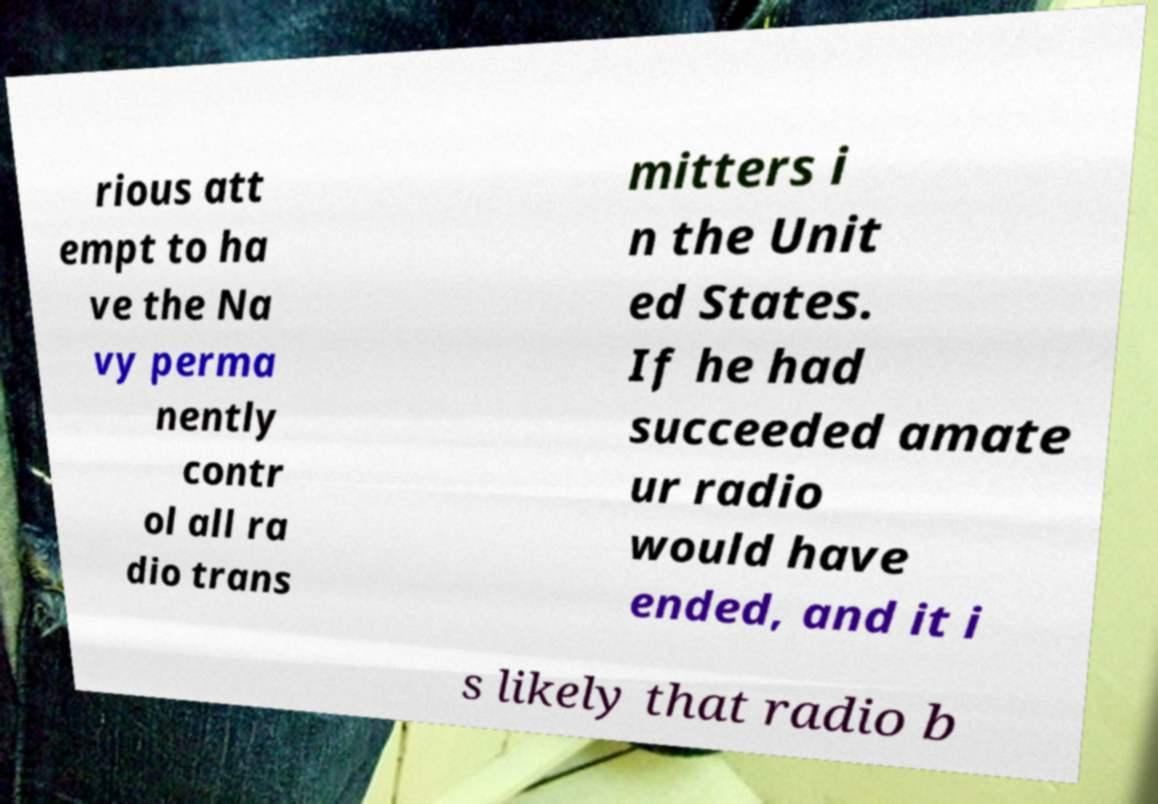Can you read and provide the text displayed in the image?This photo seems to have some interesting text. Can you extract and type it out for me? rious att empt to ha ve the Na vy perma nently contr ol all ra dio trans mitters i n the Unit ed States. If he had succeeded amate ur radio would have ended, and it i s likely that radio b 